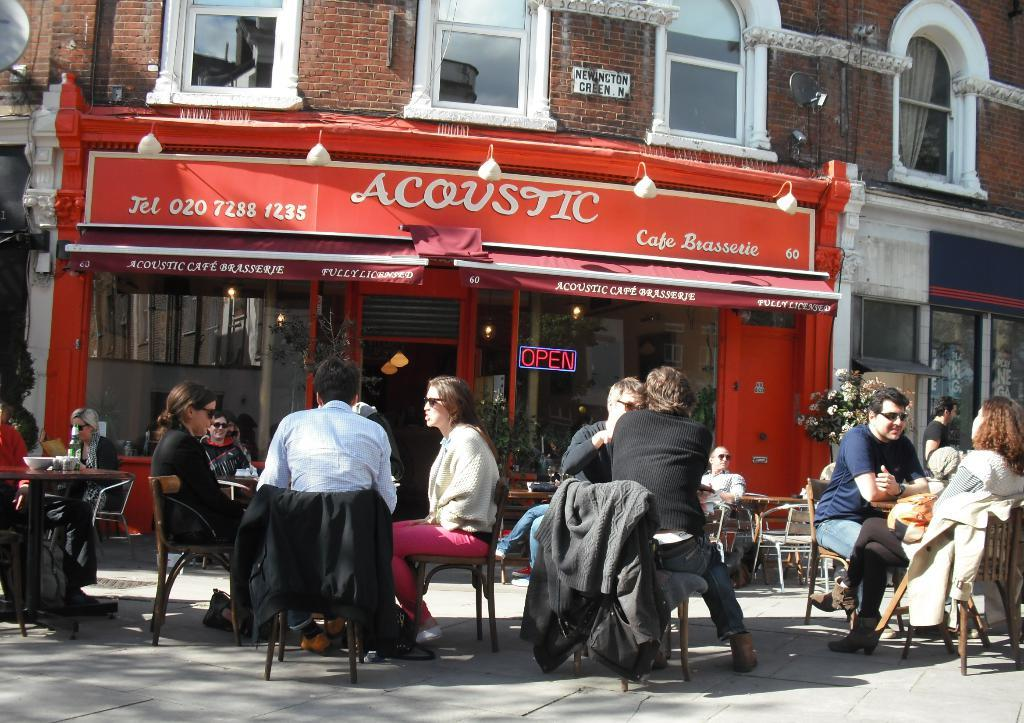What are the people in the image doing? The people in the image are sitting on chairs. What furniture is present in the image besides chairs? There are tables in the image. What objects can be seen on the tables? There are bowls and a bottle on the tables. What type of vegetation is present in the image? There are plants and flowers in the image. What type of structure is visible in the image? There is a building in the image. What other objects can be seen in the image? There are boards, a door, lights, and glasses in the image. What type of credit card is being used to purchase the crackers in the image? There is no credit card or crackers present in the image. How is the hose being used in the image? There is no hose present in the image. 